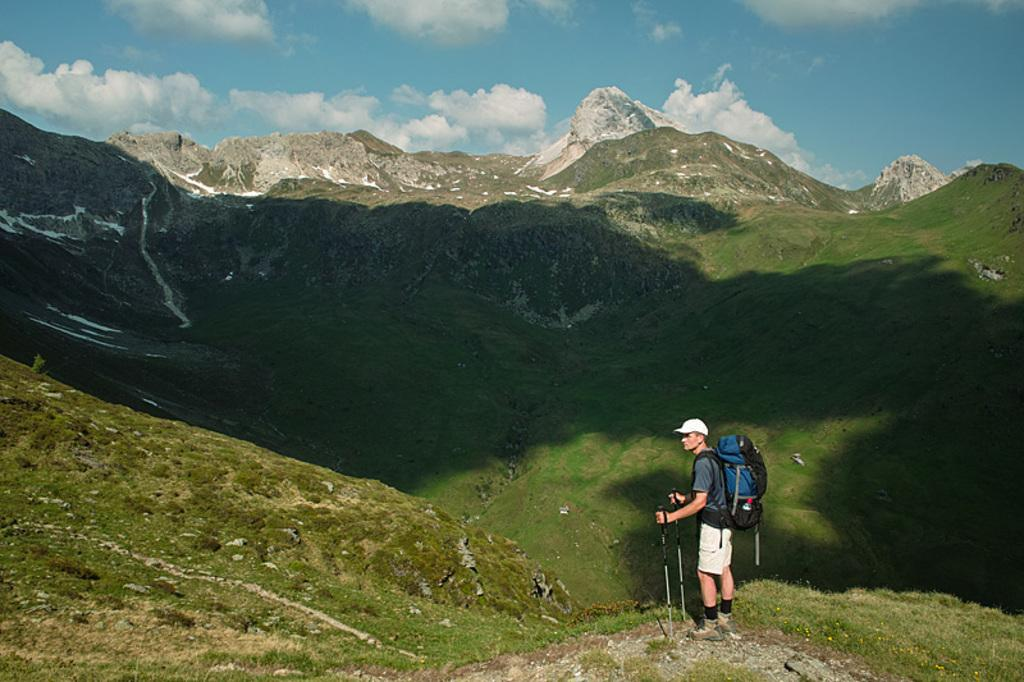What is the main subject of the image? There is a man in the image. What is the man holding in the image? The man is holding sticks. What is the man wearing in the image? The man is wearing a bag. Where is the man standing in the image? The man is standing on the grass. What can be seen in the background of the image? There are mountains and the sky visible in the background of the image. What type of machine can be seen in the image? There is no machine present in the image; it features a man holding sticks and standing on the grass with mountains and the sky in the background. 